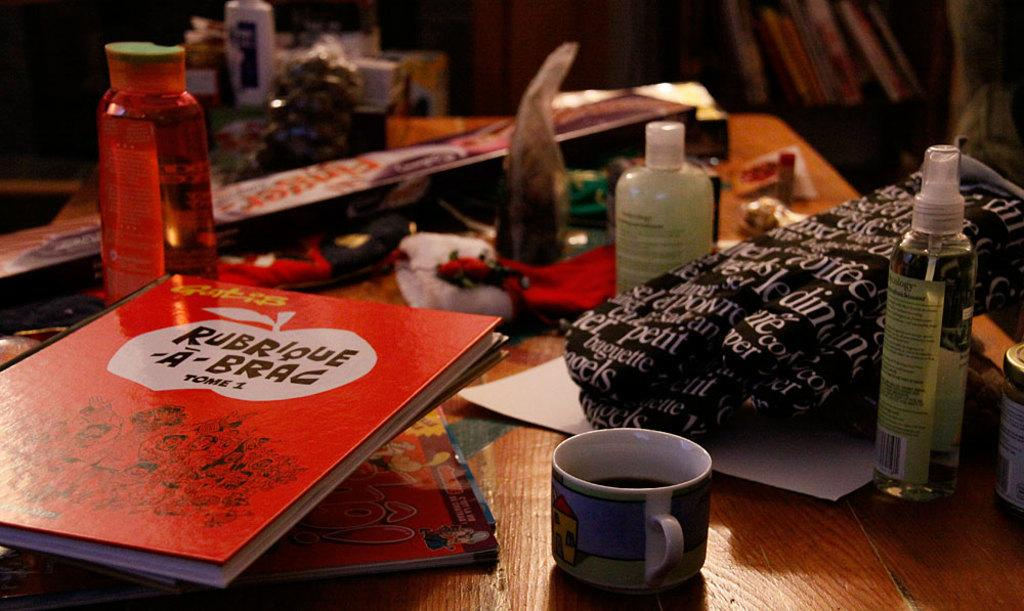<image>
Offer a succinct explanation of the picture presented. The book has A Brag written on the cover 